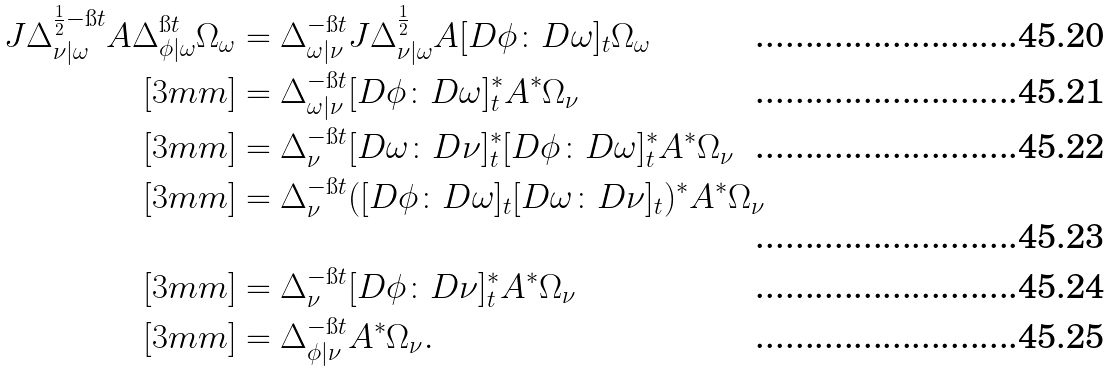<formula> <loc_0><loc_0><loc_500><loc_500>J \Delta _ { \nu | \omega } ^ { \frac { 1 } { 2 } - \i t } A \Delta _ { \phi | \omega } ^ { \i t } \Omega _ { \omega } & = \Delta _ { \omega | \nu } ^ { - \i t } J \Delta _ { \nu | \omega } ^ { \frac { 1 } { 2 } } A [ D \phi \colon D \omega ] _ { t } \Omega _ { \omega } \\ [ 3 m m ] & = \Delta _ { \omega | \nu } ^ { - \i t } [ D \phi \colon D \omega ] _ { t } ^ { \ast } A ^ { \ast } \Omega _ { \nu } \\ [ 3 m m ] & = \Delta _ { \nu } ^ { - \i t } [ D \omega \colon D \nu ] _ { t } ^ { \ast } [ D \phi \colon D \omega ] _ { t } ^ { \ast } A ^ { \ast } \Omega _ { \nu } \\ [ 3 m m ] & = \Delta _ { \nu } ^ { - \i t } ( [ D \phi \colon D \omega ] _ { t } [ D \omega \colon D \nu ] _ { t } ) ^ { \ast } A ^ { \ast } \Omega _ { \nu } \\ [ 3 m m ] & = \Delta _ { \nu } ^ { - \i t } [ D \phi \colon D \nu ] _ { t } ^ { \ast } A ^ { \ast } \Omega _ { \nu } \\ [ 3 m m ] & = \Delta _ { \phi | \nu } ^ { - \i t } A ^ { \ast } \Omega _ { \nu } .</formula> 